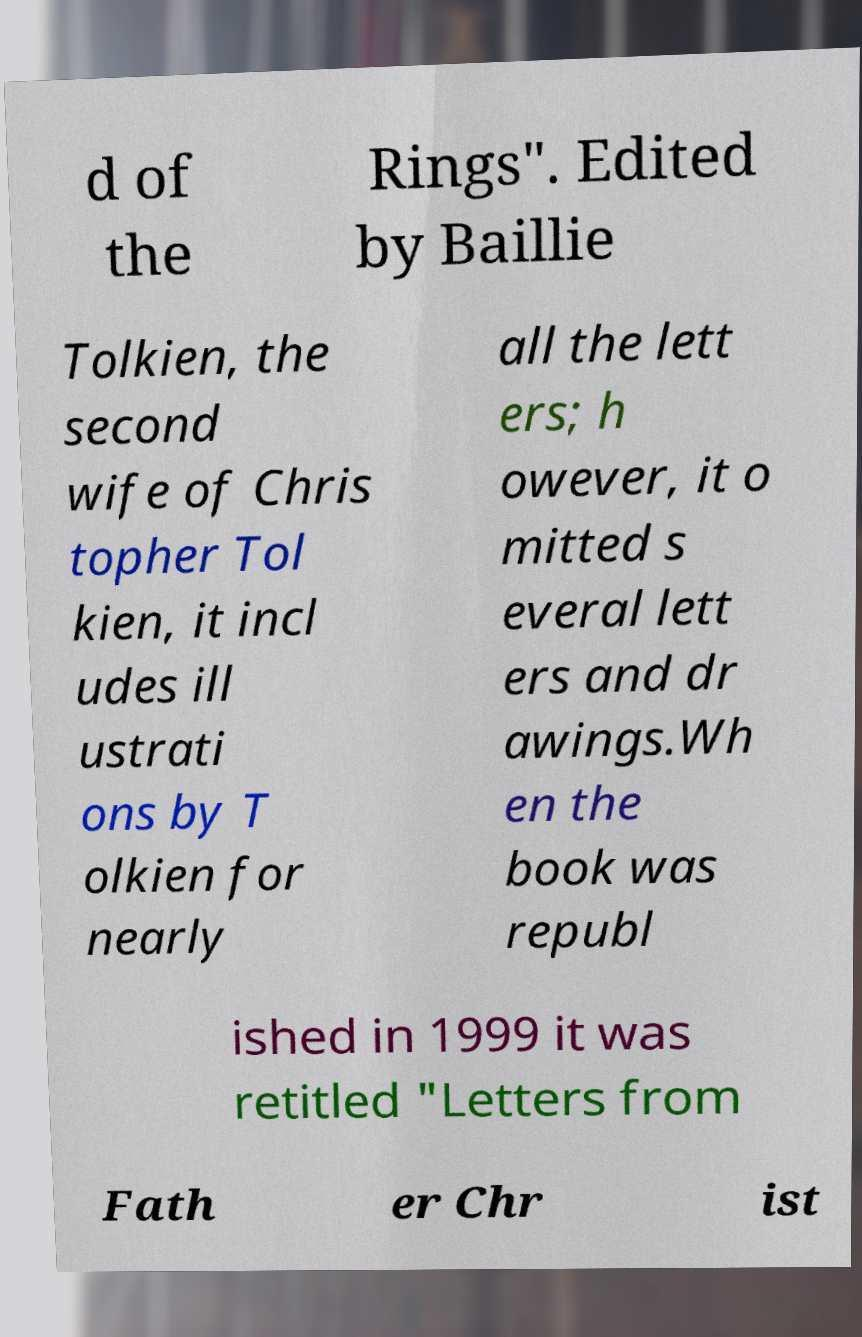Can you read and provide the text displayed in the image?This photo seems to have some interesting text. Can you extract and type it out for me? d of the Rings". Edited by Baillie Tolkien, the second wife of Chris topher Tol kien, it incl udes ill ustrati ons by T olkien for nearly all the lett ers; h owever, it o mitted s everal lett ers and dr awings.Wh en the book was republ ished in 1999 it was retitled "Letters from Fath er Chr ist 